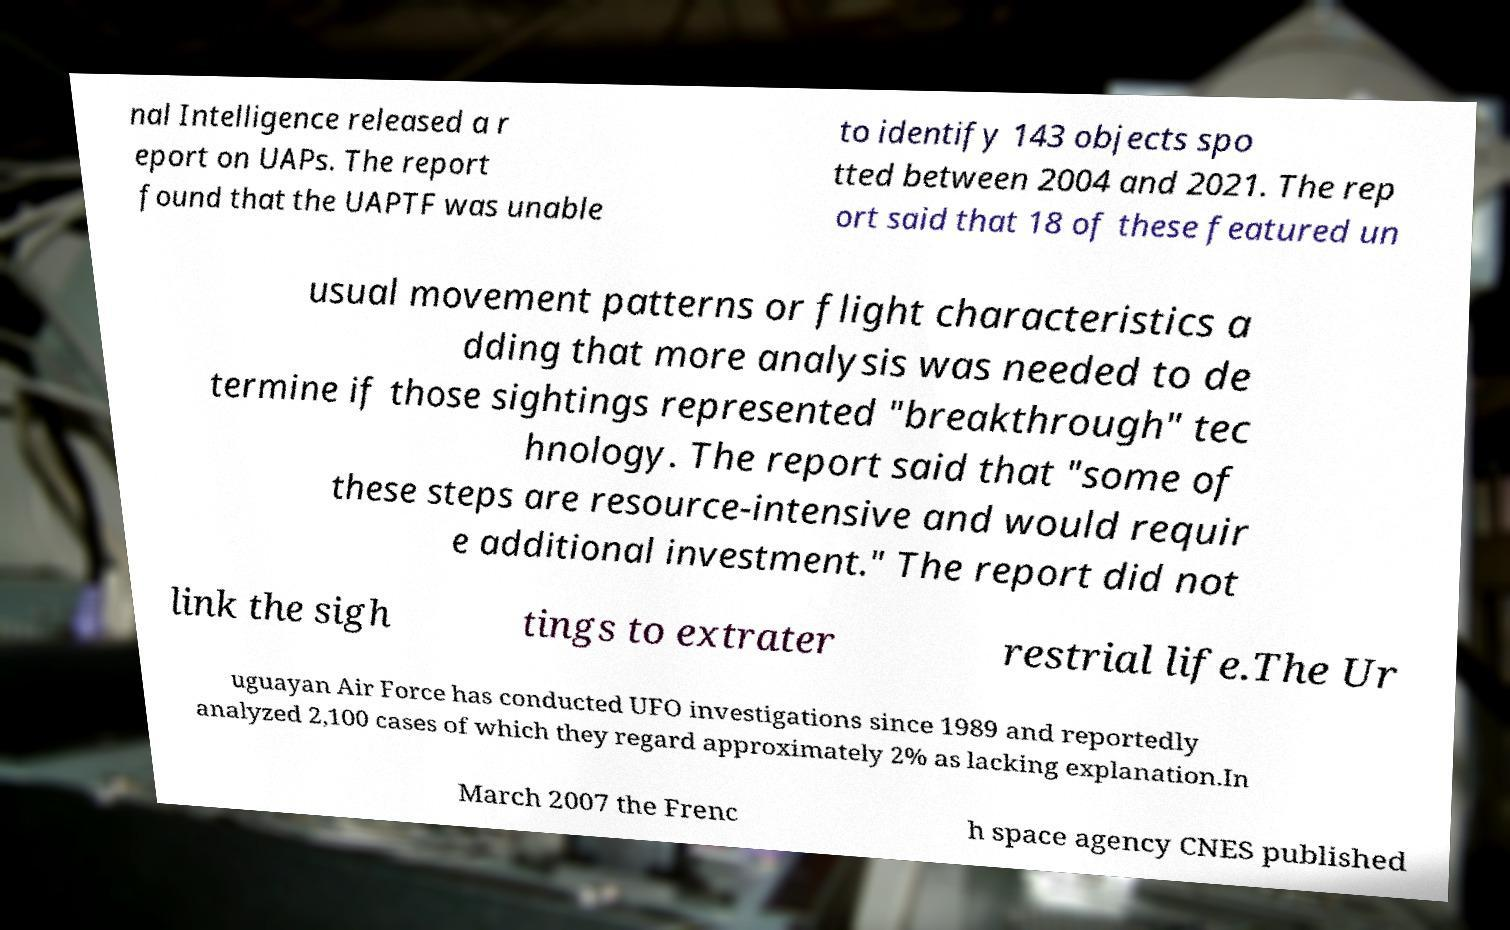Please read and relay the text visible in this image. What does it say? nal Intelligence released a r eport on UAPs. The report found that the UAPTF was unable to identify 143 objects spo tted between 2004 and 2021. The rep ort said that 18 of these featured un usual movement patterns or flight characteristics a dding that more analysis was needed to de termine if those sightings represented "breakthrough" tec hnology. The report said that "some of these steps are resource-intensive and would requir e additional investment." The report did not link the sigh tings to extrater restrial life.The Ur uguayan Air Force has conducted UFO investigations since 1989 and reportedly analyzed 2,100 cases of which they regard approximately 2% as lacking explanation.In March 2007 the Frenc h space agency CNES published 